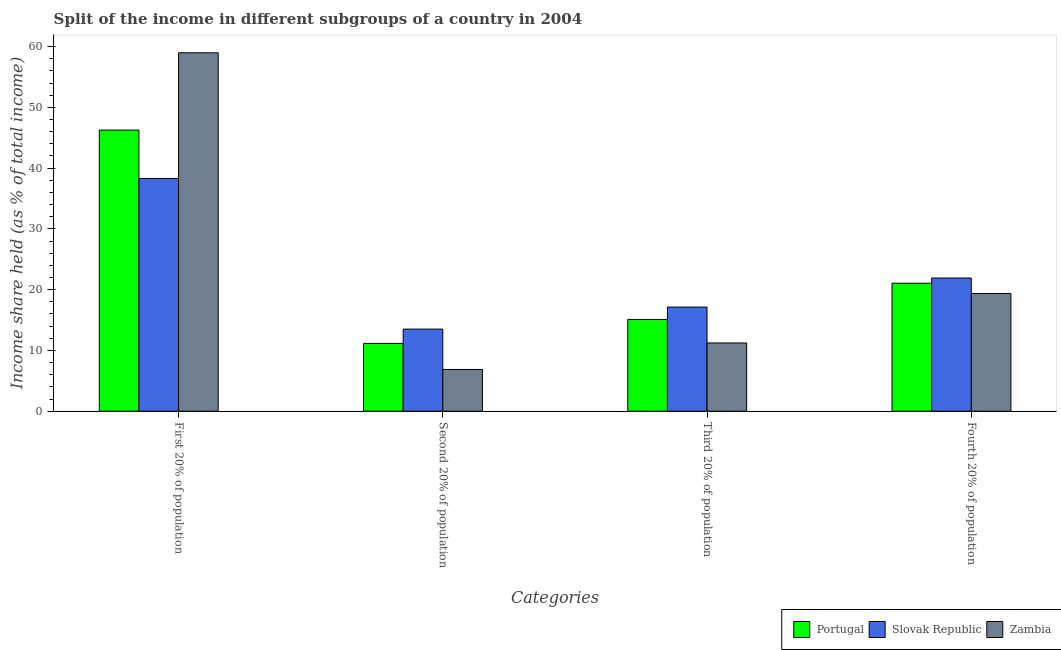How many groups of bars are there?
Give a very brief answer. 4. Are the number of bars per tick equal to the number of legend labels?
Your response must be concise. Yes. Are the number of bars on each tick of the X-axis equal?
Your answer should be compact. Yes. What is the label of the 3rd group of bars from the left?
Provide a succinct answer. Third 20% of population. Across all countries, what is the maximum share of the income held by third 20% of the population?
Provide a succinct answer. 17.14. Across all countries, what is the minimum share of the income held by fourth 20% of the population?
Make the answer very short. 19.37. In which country was the share of the income held by second 20% of the population maximum?
Keep it short and to the point. Slovak Republic. In which country was the share of the income held by third 20% of the population minimum?
Provide a succinct answer. Zambia. What is the total share of the income held by first 20% of the population in the graph?
Keep it short and to the point. 143.54. What is the difference between the share of the income held by first 20% of the population in Slovak Republic and that in Zambia?
Keep it short and to the point. -20.68. What is the difference between the share of the income held by second 20% of the population in Slovak Republic and the share of the income held by first 20% of the population in Zambia?
Your answer should be compact. -45.47. What is the average share of the income held by second 20% of the population per country?
Offer a very short reply. 10.51. What is the difference between the share of the income held by second 20% of the population and share of the income held by first 20% of the population in Portugal?
Offer a terse response. -35.1. What is the ratio of the share of the income held by third 20% of the population in Slovak Republic to that in Portugal?
Offer a terse response. 1.14. Is the difference between the share of the income held by first 20% of the population in Portugal and Slovak Republic greater than the difference between the share of the income held by third 20% of the population in Portugal and Slovak Republic?
Make the answer very short. Yes. What is the difference between the highest and the second highest share of the income held by second 20% of the population?
Offer a very short reply. 2.35. What is the difference between the highest and the lowest share of the income held by first 20% of the population?
Offer a terse response. 20.68. Is the sum of the share of the income held by second 20% of the population in Portugal and Zambia greater than the maximum share of the income held by first 20% of the population across all countries?
Provide a succinct answer. No. What does the 3rd bar from the left in Fourth 20% of population represents?
Give a very brief answer. Zambia. What does the 2nd bar from the right in First 20% of population represents?
Provide a short and direct response. Slovak Republic. How many bars are there?
Your answer should be very brief. 12. Are all the bars in the graph horizontal?
Keep it short and to the point. No. What is the difference between two consecutive major ticks on the Y-axis?
Ensure brevity in your answer.  10. How many legend labels are there?
Your answer should be very brief. 3. What is the title of the graph?
Keep it short and to the point. Split of the income in different subgroups of a country in 2004. What is the label or title of the X-axis?
Your response must be concise. Categories. What is the label or title of the Y-axis?
Make the answer very short. Income share held (as % of total income). What is the Income share held (as % of total income) in Portugal in First 20% of population?
Offer a very short reply. 46.26. What is the Income share held (as % of total income) in Slovak Republic in First 20% of population?
Give a very brief answer. 38.3. What is the Income share held (as % of total income) in Zambia in First 20% of population?
Keep it short and to the point. 58.98. What is the Income share held (as % of total income) of Portugal in Second 20% of population?
Ensure brevity in your answer.  11.16. What is the Income share held (as % of total income) in Slovak Republic in Second 20% of population?
Provide a succinct answer. 13.51. What is the Income share held (as % of total income) of Zambia in Second 20% of population?
Your answer should be very brief. 6.87. What is the Income share held (as % of total income) of Slovak Republic in Third 20% of population?
Give a very brief answer. 17.14. What is the Income share held (as % of total income) in Zambia in Third 20% of population?
Provide a short and direct response. 11.23. What is the Income share held (as % of total income) in Portugal in Fourth 20% of population?
Offer a terse response. 21.06. What is the Income share held (as % of total income) of Slovak Republic in Fourth 20% of population?
Ensure brevity in your answer.  21.92. What is the Income share held (as % of total income) of Zambia in Fourth 20% of population?
Keep it short and to the point. 19.37. Across all Categories, what is the maximum Income share held (as % of total income) in Portugal?
Offer a very short reply. 46.26. Across all Categories, what is the maximum Income share held (as % of total income) in Slovak Republic?
Offer a very short reply. 38.3. Across all Categories, what is the maximum Income share held (as % of total income) in Zambia?
Your answer should be very brief. 58.98. Across all Categories, what is the minimum Income share held (as % of total income) of Portugal?
Provide a short and direct response. 11.16. Across all Categories, what is the minimum Income share held (as % of total income) of Slovak Republic?
Your answer should be compact. 13.51. Across all Categories, what is the minimum Income share held (as % of total income) in Zambia?
Offer a terse response. 6.87. What is the total Income share held (as % of total income) of Portugal in the graph?
Keep it short and to the point. 93.58. What is the total Income share held (as % of total income) in Slovak Republic in the graph?
Offer a terse response. 90.87. What is the total Income share held (as % of total income) in Zambia in the graph?
Your answer should be very brief. 96.45. What is the difference between the Income share held (as % of total income) of Portugal in First 20% of population and that in Second 20% of population?
Provide a short and direct response. 35.1. What is the difference between the Income share held (as % of total income) of Slovak Republic in First 20% of population and that in Second 20% of population?
Keep it short and to the point. 24.79. What is the difference between the Income share held (as % of total income) of Zambia in First 20% of population and that in Second 20% of population?
Your response must be concise. 52.11. What is the difference between the Income share held (as % of total income) of Portugal in First 20% of population and that in Third 20% of population?
Provide a succinct answer. 31.16. What is the difference between the Income share held (as % of total income) of Slovak Republic in First 20% of population and that in Third 20% of population?
Your answer should be very brief. 21.16. What is the difference between the Income share held (as % of total income) of Zambia in First 20% of population and that in Third 20% of population?
Ensure brevity in your answer.  47.75. What is the difference between the Income share held (as % of total income) in Portugal in First 20% of population and that in Fourth 20% of population?
Keep it short and to the point. 25.2. What is the difference between the Income share held (as % of total income) of Slovak Republic in First 20% of population and that in Fourth 20% of population?
Offer a very short reply. 16.38. What is the difference between the Income share held (as % of total income) in Zambia in First 20% of population and that in Fourth 20% of population?
Offer a very short reply. 39.61. What is the difference between the Income share held (as % of total income) in Portugal in Second 20% of population and that in Third 20% of population?
Keep it short and to the point. -3.94. What is the difference between the Income share held (as % of total income) of Slovak Republic in Second 20% of population and that in Third 20% of population?
Ensure brevity in your answer.  -3.63. What is the difference between the Income share held (as % of total income) of Zambia in Second 20% of population and that in Third 20% of population?
Make the answer very short. -4.36. What is the difference between the Income share held (as % of total income) of Portugal in Second 20% of population and that in Fourth 20% of population?
Offer a very short reply. -9.9. What is the difference between the Income share held (as % of total income) in Slovak Republic in Second 20% of population and that in Fourth 20% of population?
Your answer should be very brief. -8.41. What is the difference between the Income share held (as % of total income) of Zambia in Second 20% of population and that in Fourth 20% of population?
Offer a very short reply. -12.5. What is the difference between the Income share held (as % of total income) in Portugal in Third 20% of population and that in Fourth 20% of population?
Ensure brevity in your answer.  -5.96. What is the difference between the Income share held (as % of total income) in Slovak Republic in Third 20% of population and that in Fourth 20% of population?
Your answer should be very brief. -4.78. What is the difference between the Income share held (as % of total income) in Zambia in Third 20% of population and that in Fourth 20% of population?
Your response must be concise. -8.14. What is the difference between the Income share held (as % of total income) of Portugal in First 20% of population and the Income share held (as % of total income) of Slovak Republic in Second 20% of population?
Your answer should be compact. 32.75. What is the difference between the Income share held (as % of total income) in Portugal in First 20% of population and the Income share held (as % of total income) in Zambia in Second 20% of population?
Provide a succinct answer. 39.39. What is the difference between the Income share held (as % of total income) in Slovak Republic in First 20% of population and the Income share held (as % of total income) in Zambia in Second 20% of population?
Provide a succinct answer. 31.43. What is the difference between the Income share held (as % of total income) in Portugal in First 20% of population and the Income share held (as % of total income) in Slovak Republic in Third 20% of population?
Provide a succinct answer. 29.12. What is the difference between the Income share held (as % of total income) of Portugal in First 20% of population and the Income share held (as % of total income) of Zambia in Third 20% of population?
Give a very brief answer. 35.03. What is the difference between the Income share held (as % of total income) in Slovak Republic in First 20% of population and the Income share held (as % of total income) in Zambia in Third 20% of population?
Provide a succinct answer. 27.07. What is the difference between the Income share held (as % of total income) in Portugal in First 20% of population and the Income share held (as % of total income) in Slovak Republic in Fourth 20% of population?
Offer a very short reply. 24.34. What is the difference between the Income share held (as % of total income) of Portugal in First 20% of population and the Income share held (as % of total income) of Zambia in Fourth 20% of population?
Provide a succinct answer. 26.89. What is the difference between the Income share held (as % of total income) of Slovak Republic in First 20% of population and the Income share held (as % of total income) of Zambia in Fourth 20% of population?
Provide a short and direct response. 18.93. What is the difference between the Income share held (as % of total income) of Portugal in Second 20% of population and the Income share held (as % of total income) of Slovak Republic in Third 20% of population?
Your response must be concise. -5.98. What is the difference between the Income share held (as % of total income) in Portugal in Second 20% of population and the Income share held (as % of total income) in Zambia in Third 20% of population?
Make the answer very short. -0.07. What is the difference between the Income share held (as % of total income) in Slovak Republic in Second 20% of population and the Income share held (as % of total income) in Zambia in Third 20% of population?
Give a very brief answer. 2.28. What is the difference between the Income share held (as % of total income) in Portugal in Second 20% of population and the Income share held (as % of total income) in Slovak Republic in Fourth 20% of population?
Provide a succinct answer. -10.76. What is the difference between the Income share held (as % of total income) in Portugal in Second 20% of population and the Income share held (as % of total income) in Zambia in Fourth 20% of population?
Offer a terse response. -8.21. What is the difference between the Income share held (as % of total income) in Slovak Republic in Second 20% of population and the Income share held (as % of total income) in Zambia in Fourth 20% of population?
Give a very brief answer. -5.86. What is the difference between the Income share held (as % of total income) of Portugal in Third 20% of population and the Income share held (as % of total income) of Slovak Republic in Fourth 20% of population?
Your answer should be very brief. -6.82. What is the difference between the Income share held (as % of total income) of Portugal in Third 20% of population and the Income share held (as % of total income) of Zambia in Fourth 20% of population?
Keep it short and to the point. -4.27. What is the difference between the Income share held (as % of total income) of Slovak Republic in Third 20% of population and the Income share held (as % of total income) of Zambia in Fourth 20% of population?
Provide a short and direct response. -2.23. What is the average Income share held (as % of total income) in Portugal per Categories?
Your answer should be very brief. 23.39. What is the average Income share held (as % of total income) in Slovak Republic per Categories?
Keep it short and to the point. 22.72. What is the average Income share held (as % of total income) of Zambia per Categories?
Provide a short and direct response. 24.11. What is the difference between the Income share held (as % of total income) in Portugal and Income share held (as % of total income) in Slovak Republic in First 20% of population?
Keep it short and to the point. 7.96. What is the difference between the Income share held (as % of total income) in Portugal and Income share held (as % of total income) in Zambia in First 20% of population?
Your answer should be very brief. -12.72. What is the difference between the Income share held (as % of total income) in Slovak Republic and Income share held (as % of total income) in Zambia in First 20% of population?
Provide a succinct answer. -20.68. What is the difference between the Income share held (as % of total income) in Portugal and Income share held (as % of total income) in Slovak Republic in Second 20% of population?
Give a very brief answer. -2.35. What is the difference between the Income share held (as % of total income) of Portugal and Income share held (as % of total income) of Zambia in Second 20% of population?
Give a very brief answer. 4.29. What is the difference between the Income share held (as % of total income) of Slovak Republic and Income share held (as % of total income) of Zambia in Second 20% of population?
Make the answer very short. 6.64. What is the difference between the Income share held (as % of total income) in Portugal and Income share held (as % of total income) in Slovak Republic in Third 20% of population?
Your answer should be very brief. -2.04. What is the difference between the Income share held (as % of total income) in Portugal and Income share held (as % of total income) in Zambia in Third 20% of population?
Give a very brief answer. 3.87. What is the difference between the Income share held (as % of total income) in Slovak Republic and Income share held (as % of total income) in Zambia in Third 20% of population?
Offer a terse response. 5.91. What is the difference between the Income share held (as % of total income) in Portugal and Income share held (as % of total income) in Slovak Republic in Fourth 20% of population?
Your response must be concise. -0.86. What is the difference between the Income share held (as % of total income) of Portugal and Income share held (as % of total income) of Zambia in Fourth 20% of population?
Offer a terse response. 1.69. What is the difference between the Income share held (as % of total income) in Slovak Republic and Income share held (as % of total income) in Zambia in Fourth 20% of population?
Provide a short and direct response. 2.55. What is the ratio of the Income share held (as % of total income) in Portugal in First 20% of population to that in Second 20% of population?
Offer a very short reply. 4.15. What is the ratio of the Income share held (as % of total income) of Slovak Republic in First 20% of population to that in Second 20% of population?
Your response must be concise. 2.83. What is the ratio of the Income share held (as % of total income) of Zambia in First 20% of population to that in Second 20% of population?
Offer a terse response. 8.59. What is the ratio of the Income share held (as % of total income) of Portugal in First 20% of population to that in Third 20% of population?
Offer a terse response. 3.06. What is the ratio of the Income share held (as % of total income) in Slovak Republic in First 20% of population to that in Third 20% of population?
Make the answer very short. 2.23. What is the ratio of the Income share held (as % of total income) in Zambia in First 20% of population to that in Third 20% of population?
Make the answer very short. 5.25. What is the ratio of the Income share held (as % of total income) of Portugal in First 20% of population to that in Fourth 20% of population?
Offer a terse response. 2.2. What is the ratio of the Income share held (as % of total income) in Slovak Republic in First 20% of population to that in Fourth 20% of population?
Your answer should be very brief. 1.75. What is the ratio of the Income share held (as % of total income) of Zambia in First 20% of population to that in Fourth 20% of population?
Your answer should be very brief. 3.04. What is the ratio of the Income share held (as % of total income) in Portugal in Second 20% of population to that in Third 20% of population?
Offer a terse response. 0.74. What is the ratio of the Income share held (as % of total income) of Slovak Republic in Second 20% of population to that in Third 20% of population?
Your response must be concise. 0.79. What is the ratio of the Income share held (as % of total income) in Zambia in Second 20% of population to that in Third 20% of population?
Your answer should be very brief. 0.61. What is the ratio of the Income share held (as % of total income) in Portugal in Second 20% of population to that in Fourth 20% of population?
Give a very brief answer. 0.53. What is the ratio of the Income share held (as % of total income) of Slovak Republic in Second 20% of population to that in Fourth 20% of population?
Your answer should be very brief. 0.62. What is the ratio of the Income share held (as % of total income) of Zambia in Second 20% of population to that in Fourth 20% of population?
Ensure brevity in your answer.  0.35. What is the ratio of the Income share held (as % of total income) in Portugal in Third 20% of population to that in Fourth 20% of population?
Provide a short and direct response. 0.72. What is the ratio of the Income share held (as % of total income) of Slovak Republic in Third 20% of population to that in Fourth 20% of population?
Offer a terse response. 0.78. What is the ratio of the Income share held (as % of total income) of Zambia in Third 20% of population to that in Fourth 20% of population?
Make the answer very short. 0.58. What is the difference between the highest and the second highest Income share held (as % of total income) of Portugal?
Your answer should be compact. 25.2. What is the difference between the highest and the second highest Income share held (as % of total income) in Slovak Republic?
Provide a succinct answer. 16.38. What is the difference between the highest and the second highest Income share held (as % of total income) in Zambia?
Ensure brevity in your answer.  39.61. What is the difference between the highest and the lowest Income share held (as % of total income) in Portugal?
Offer a very short reply. 35.1. What is the difference between the highest and the lowest Income share held (as % of total income) of Slovak Republic?
Ensure brevity in your answer.  24.79. What is the difference between the highest and the lowest Income share held (as % of total income) in Zambia?
Your answer should be very brief. 52.11. 